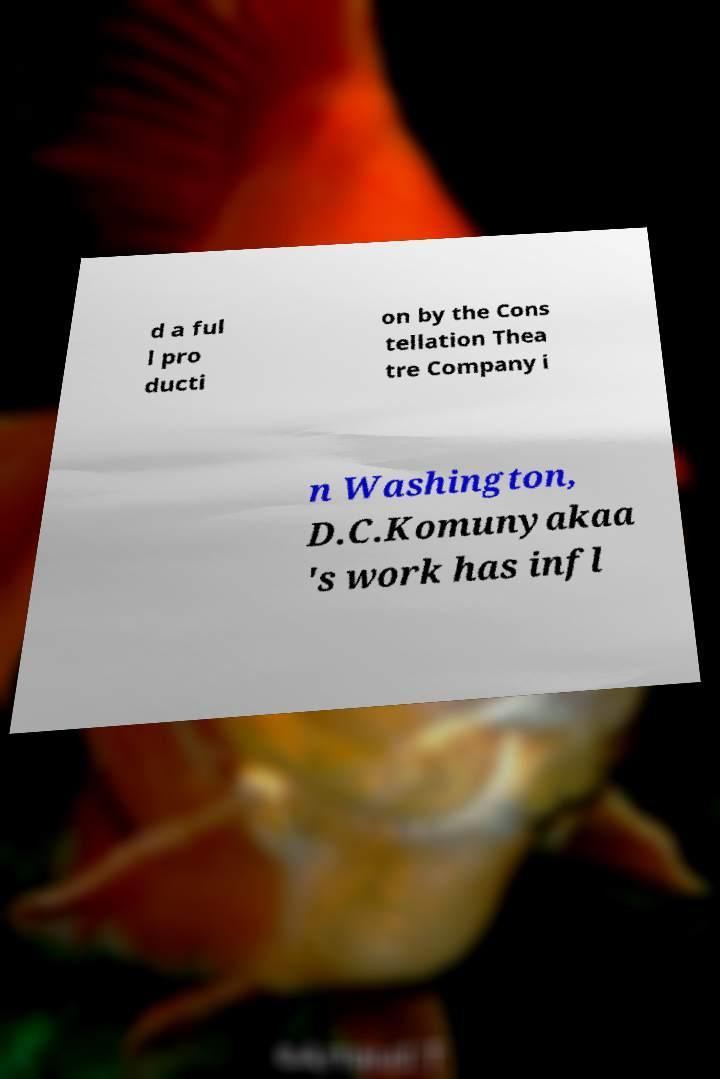There's text embedded in this image that I need extracted. Can you transcribe it verbatim? d a ful l pro ducti on by the Cons tellation Thea tre Company i n Washington, D.C.Komunyakaa 's work has infl 